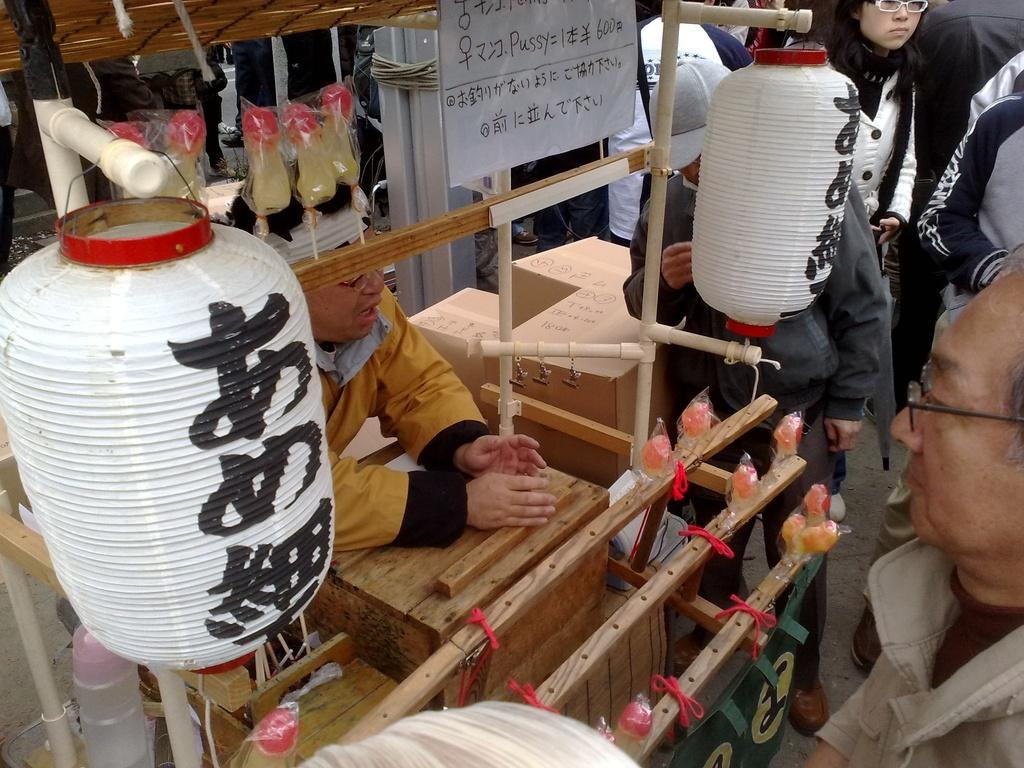What can be seen in the image in terms of human presence? There are people standing in the image. What type of material is used for some of the objects in the image? There are wooden objects in the image. Can you describe any other objects present in the image? There are other objects in the image, but their specific details are not mentioned in the provided facts. How many years does the arm of the wooden object have? There is no mention of an arm or a wooden object with a specific number of years in the provided facts. 